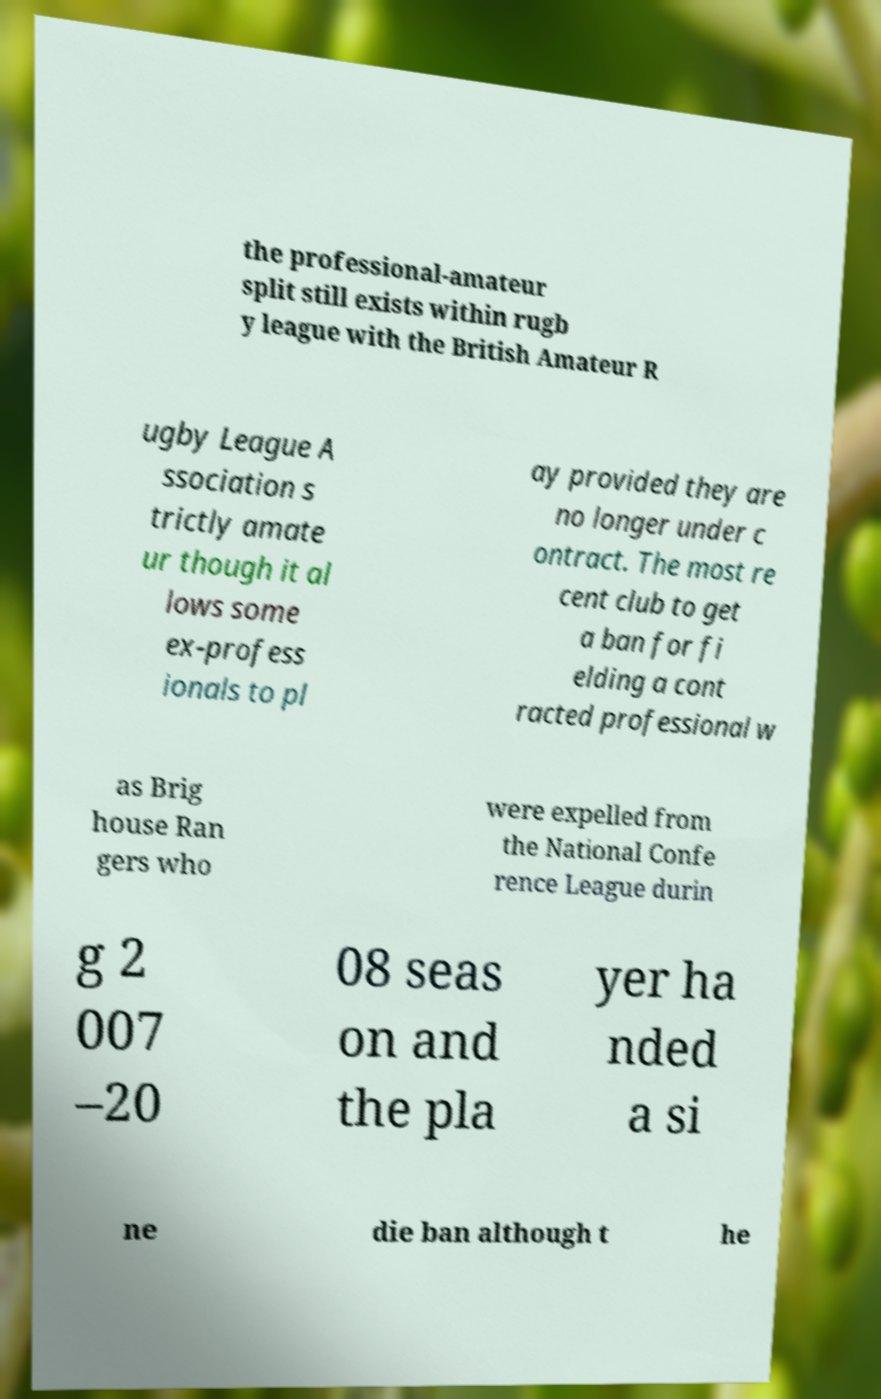For documentation purposes, I need the text within this image transcribed. Could you provide that? the professional-amateur split still exists within rugb y league with the British Amateur R ugby League A ssociation s trictly amate ur though it al lows some ex-profess ionals to pl ay provided they are no longer under c ontract. The most re cent club to get a ban for fi elding a cont racted professional w as Brig house Ran gers who were expelled from the National Confe rence League durin g 2 007 –20 08 seas on and the pla yer ha nded a si ne die ban although t he 